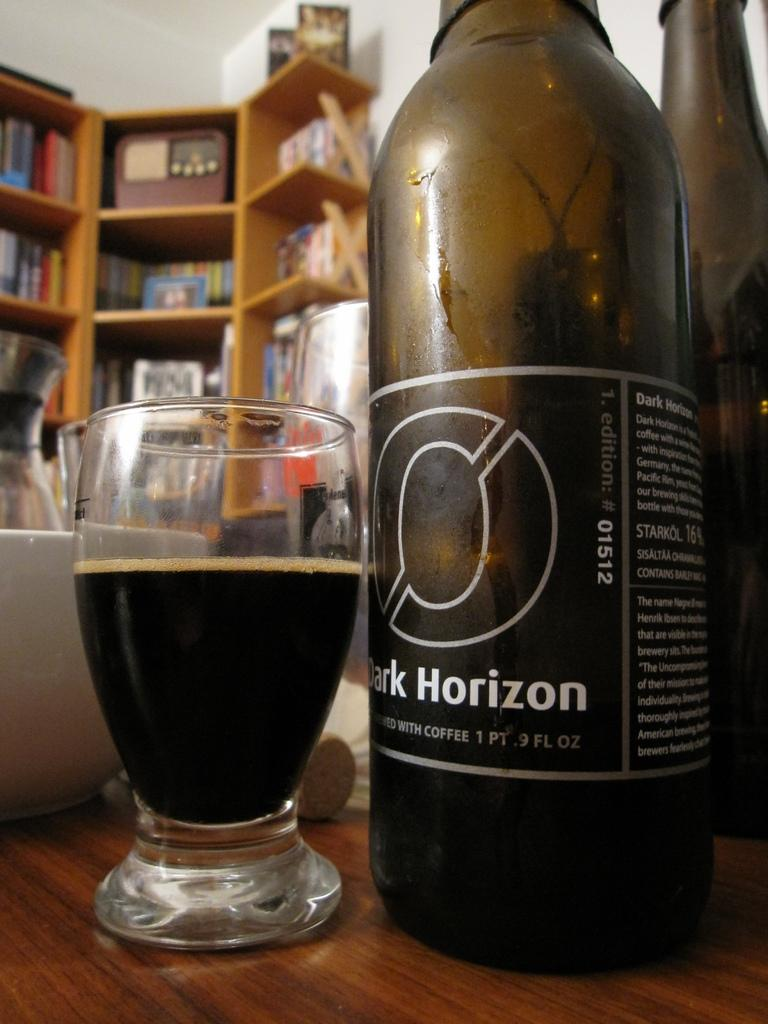<image>
Share a concise interpretation of the image provided. the word Horizon is on a wine bottle 